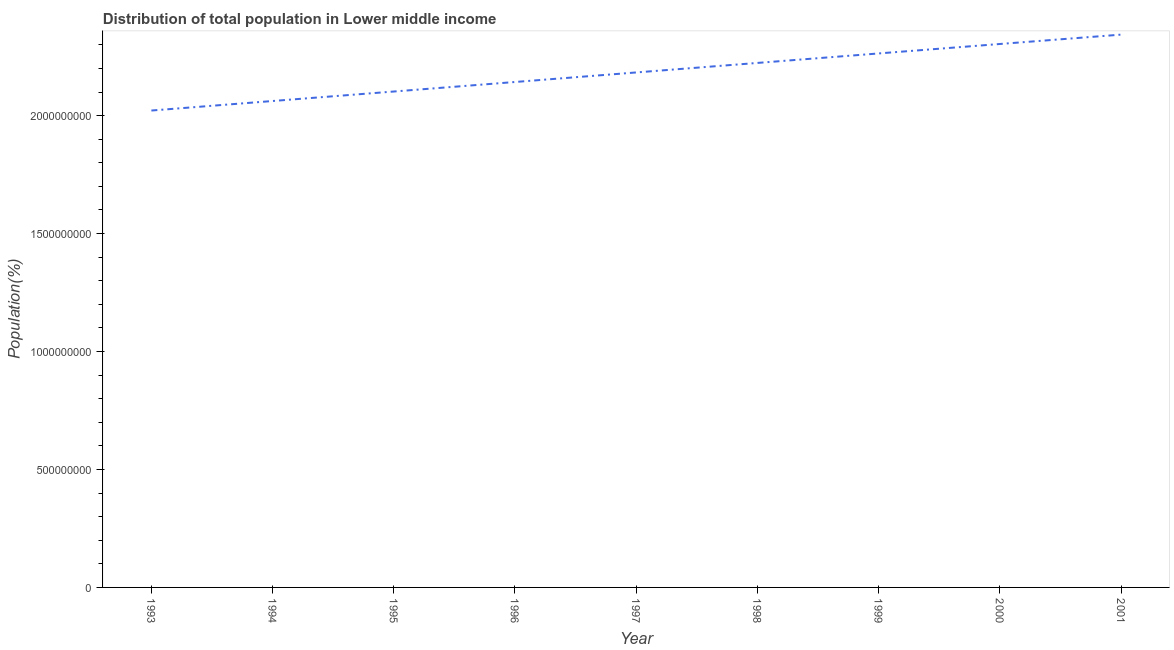What is the population in 1994?
Give a very brief answer. 2.06e+09. Across all years, what is the maximum population?
Keep it short and to the point. 2.34e+09. Across all years, what is the minimum population?
Provide a short and direct response. 2.02e+09. In which year was the population maximum?
Offer a terse response. 2001. In which year was the population minimum?
Your answer should be very brief. 1993. What is the sum of the population?
Your answer should be very brief. 1.96e+1. What is the difference between the population in 1995 and 2000?
Provide a short and direct response. -2.01e+08. What is the average population per year?
Make the answer very short. 2.18e+09. What is the median population?
Offer a terse response. 2.18e+09. Do a majority of the years between 1996 and 1993 (inclusive) have population greater than 1600000000 %?
Provide a short and direct response. Yes. What is the ratio of the population in 1997 to that in 2000?
Make the answer very short. 0.95. What is the difference between the highest and the second highest population?
Your answer should be compact. 3.97e+07. Is the sum of the population in 1993 and 1995 greater than the maximum population across all years?
Your answer should be compact. Yes. What is the difference between the highest and the lowest population?
Give a very brief answer. 3.22e+08. Does the population monotonically increase over the years?
Your answer should be very brief. Yes. What is the difference between two consecutive major ticks on the Y-axis?
Offer a terse response. 5.00e+08. Are the values on the major ticks of Y-axis written in scientific E-notation?
Provide a short and direct response. No. What is the title of the graph?
Make the answer very short. Distribution of total population in Lower middle income . What is the label or title of the X-axis?
Keep it short and to the point. Year. What is the label or title of the Y-axis?
Keep it short and to the point. Population(%). What is the Population(%) in 1993?
Your answer should be compact. 2.02e+09. What is the Population(%) in 1994?
Give a very brief answer. 2.06e+09. What is the Population(%) in 1995?
Make the answer very short. 2.10e+09. What is the Population(%) of 1996?
Provide a short and direct response. 2.14e+09. What is the Population(%) of 1997?
Give a very brief answer. 2.18e+09. What is the Population(%) in 1998?
Make the answer very short. 2.22e+09. What is the Population(%) in 1999?
Provide a short and direct response. 2.26e+09. What is the Population(%) in 2000?
Provide a short and direct response. 2.30e+09. What is the Population(%) of 2001?
Give a very brief answer. 2.34e+09. What is the difference between the Population(%) in 1993 and 1994?
Provide a succinct answer. -4.04e+07. What is the difference between the Population(%) in 1993 and 1995?
Your response must be concise. -8.06e+07. What is the difference between the Population(%) in 1993 and 1996?
Offer a very short reply. -1.21e+08. What is the difference between the Population(%) in 1993 and 1997?
Your answer should be very brief. -1.61e+08. What is the difference between the Population(%) in 1993 and 1998?
Ensure brevity in your answer.  -2.02e+08. What is the difference between the Population(%) in 1993 and 1999?
Give a very brief answer. -2.42e+08. What is the difference between the Population(%) in 1993 and 2000?
Keep it short and to the point. -2.82e+08. What is the difference between the Population(%) in 1993 and 2001?
Your answer should be very brief. -3.22e+08. What is the difference between the Population(%) in 1994 and 1995?
Offer a terse response. -4.03e+07. What is the difference between the Population(%) in 1994 and 1996?
Your response must be concise. -8.06e+07. What is the difference between the Population(%) in 1994 and 1997?
Your response must be concise. -1.21e+08. What is the difference between the Population(%) in 1994 and 1998?
Your answer should be compact. -1.61e+08. What is the difference between the Population(%) in 1994 and 1999?
Your answer should be compact. -2.02e+08. What is the difference between the Population(%) in 1994 and 2000?
Provide a short and direct response. -2.42e+08. What is the difference between the Population(%) in 1994 and 2001?
Provide a succinct answer. -2.81e+08. What is the difference between the Population(%) in 1995 and 1996?
Provide a short and direct response. -4.03e+07. What is the difference between the Population(%) in 1995 and 1997?
Ensure brevity in your answer.  -8.08e+07. What is the difference between the Population(%) in 1995 and 1998?
Keep it short and to the point. -1.21e+08. What is the difference between the Population(%) in 1995 and 1999?
Make the answer very short. -1.61e+08. What is the difference between the Population(%) in 1995 and 2000?
Provide a succinct answer. -2.01e+08. What is the difference between the Population(%) in 1995 and 2001?
Make the answer very short. -2.41e+08. What is the difference between the Population(%) in 1996 and 1997?
Offer a very short reply. -4.05e+07. What is the difference between the Population(%) in 1996 and 1998?
Provide a short and direct response. -8.08e+07. What is the difference between the Population(%) in 1996 and 1999?
Provide a short and direct response. -1.21e+08. What is the difference between the Population(%) in 1996 and 2000?
Your answer should be very brief. -1.61e+08. What is the difference between the Population(%) in 1996 and 2001?
Make the answer very short. -2.01e+08. What is the difference between the Population(%) in 1997 and 1998?
Your answer should be compact. -4.03e+07. What is the difference between the Population(%) in 1997 and 1999?
Your response must be concise. -8.05e+07. What is the difference between the Population(%) in 1997 and 2000?
Your answer should be very brief. -1.21e+08. What is the difference between the Population(%) in 1997 and 2001?
Make the answer very short. -1.60e+08. What is the difference between the Population(%) in 1998 and 1999?
Provide a succinct answer. -4.02e+07. What is the difference between the Population(%) in 1998 and 2000?
Your answer should be compact. -8.03e+07. What is the difference between the Population(%) in 1998 and 2001?
Make the answer very short. -1.20e+08. What is the difference between the Population(%) in 1999 and 2000?
Offer a very short reply. -4.01e+07. What is the difference between the Population(%) in 1999 and 2001?
Your response must be concise. -7.98e+07. What is the difference between the Population(%) in 2000 and 2001?
Your response must be concise. -3.97e+07. What is the ratio of the Population(%) in 1993 to that in 1994?
Give a very brief answer. 0.98. What is the ratio of the Population(%) in 1993 to that in 1995?
Offer a terse response. 0.96. What is the ratio of the Population(%) in 1993 to that in 1996?
Provide a short and direct response. 0.94. What is the ratio of the Population(%) in 1993 to that in 1997?
Provide a short and direct response. 0.93. What is the ratio of the Population(%) in 1993 to that in 1998?
Keep it short and to the point. 0.91. What is the ratio of the Population(%) in 1993 to that in 1999?
Give a very brief answer. 0.89. What is the ratio of the Population(%) in 1993 to that in 2000?
Provide a short and direct response. 0.88. What is the ratio of the Population(%) in 1993 to that in 2001?
Your response must be concise. 0.86. What is the ratio of the Population(%) in 1994 to that in 1996?
Your answer should be compact. 0.96. What is the ratio of the Population(%) in 1994 to that in 1997?
Offer a very short reply. 0.94. What is the ratio of the Population(%) in 1994 to that in 1998?
Your response must be concise. 0.93. What is the ratio of the Population(%) in 1994 to that in 1999?
Keep it short and to the point. 0.91. What is the ratio of the Population(%) in 1994 to that in 2000?
Your answer should be compact. 0.9. What is the ratio of the Population(%) in 1995 to that in 1997?
Keep it short and to the point. 0.96. What is the ratio of the Population(%) in 1995 to that in 1998?
Offer a very short reply. 0.95. What is the ratio of the Population(%) in 1995 to that in 1999?
Your answer should be very brief. 0.93. What is the ratio of the Population(%) in 1995 to that in 2000?
Your answer should be compact. 0.91. What is the ratio of the Population(%) in 1995 to that in 2001?
Your response must be concise. 0.9. What is the ratio of the Population(%) in 1996 to that in 1997?
Your response must be concise. 0.98. What is the ratio of the Population(%) in 1996 to that in 1999?
Offer a very short reply. 0.95. What is the ratio of the Population(%) in 1996 to that in 2001?
Make the answer very short. 0.91. What is the ratio of the Population(%) in 1997 to that in 2000?
Offer a very short reply. 0.95. What is the ratio of the Population(%) in 1997 to that in 2001?
Offer a terse response. 0.93. What is the ratio of the Population(%) in 1998 to that in 2000?
Make the answer very short. 0.96. What is the ratio of the Population(%) in 1998 to that in 2001?
Ensure brevity in your answer.  0.95. What is the ratio of the Population(%) in 2000 to that in 2001?
Give a very brief answer. 0.98. 